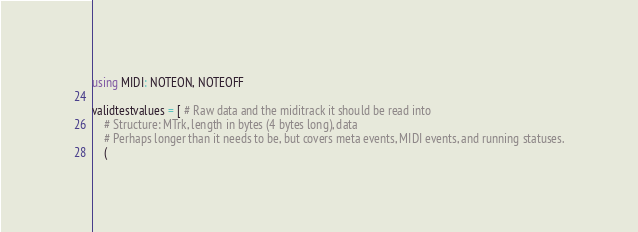Convert code to text. <code><loc_0><loc_0><loc_500><loc_500><_Julia_>using MIDI: NOTEON, NOTEOFF

validtestvalues = [ # Raw data and the miditrack it should be read into
    # Structure: MTrk, length in bytes (4 bytes long), data
    # Perhaps longer than it needs to be, but covers meta events, MIDI events, and running statuses.
    (</code> 